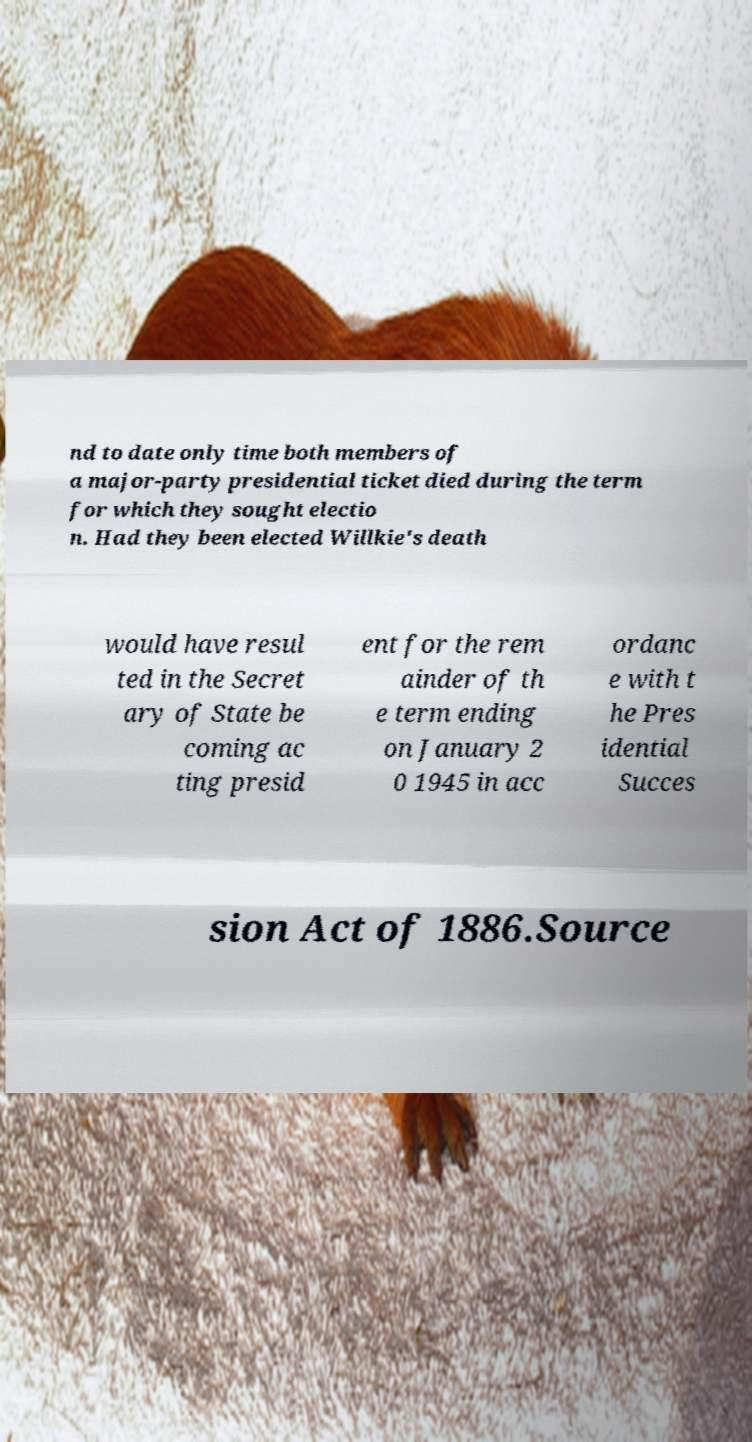Can you accurately transcribe the text from the provided image for me? nd to date only time both members of a major-party presidential ticket died during the term for which they sought electio n. Had they been elected Willkie's death would have resul ted in the Secret ary of State be coming ac ting presid ent for the rem ainder of th e term ending on January 2 0 1945 in acc ordanc e with t he Pres idential Succes sion Act of 1886.Source 